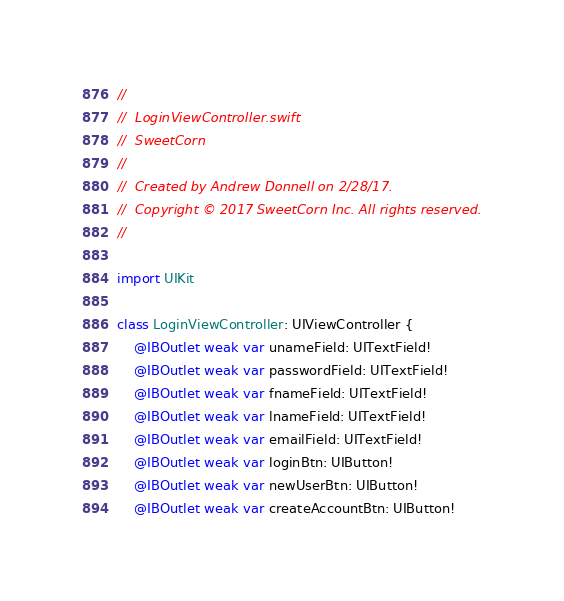<code> <loc_0><loc_0><loc_500><loc_500><_Swift_>//
//  LoginViewController.swift
//  SweetCorn
//
//  Created by Andrew Donnell on 2/28/17.
//  Copyright © 2017 SweetCorn Inc. All rights reserved.
//

import UIKit

class LoginViewController: UIViewController {
    @IBOutlet weak var unameField: UITextField!
    @IBOutlet weak var passwordField: UITextField!
    @IBOutlet weak var fnameField: UITextField!
    @IBOutlet weak var lnameField: UITextField!
    @IBOutlet weak var emailField: UITextField!
    @IBOutlet weak var loginBtn: UIButton!
    @IBOutlet weak var newUserBtn: UIButton!
    @IBOutlet weak var createAccountBtn: UIButton!</code> 